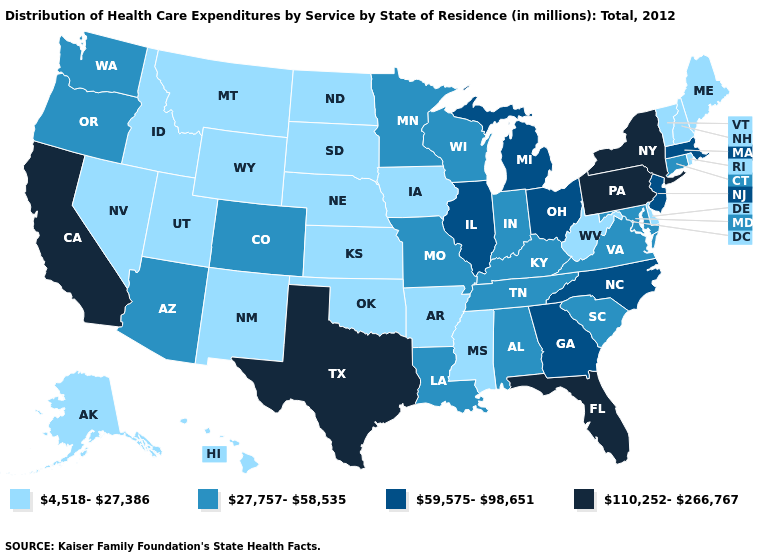Does Ohio have the highest value in the MidWest?
Write a very short answer. Yes. Which states have the highest value in the USA?
Be succinct. California, Florida, New York, Pennsylvania, Texas. What is the value of Washington?
Give a very brief answer. 27,757-58,535. Name the states that have a value in the range 27,757-58,535?
Concise answer only. Alabama, Arizona, Colorado, Connecticut, Indiana, Kentucky, Louisiana, Maryland, Minnesota, Missouri, Oregon, South Carolina, Tennessee, Virginia, Washington, Wisconsin. Does New Jersey have the same value as Nevada?
Short answer required. No. Does Missouri have the highest value in the USA?
Quick response, please. No. What is the value of Ohio?
Write a very short answer. 59,575-98,651. How many symbols are there in the legend?
Be succinct. 4. Among the states that border Utah , which have the highest value?
Answer briefly. Arizona, Colorado. What is the highest value in states that border Alabama?
Quick response, please. 110,252-266,767. What is the value of Missouri?
Be succinct. 27,757-58,535. Name the states that have a value in the range 59,575-98,651?
Short answer required. Georgia, Illinois, Massachusetts, Michigan, New Jersey, North Carolina, Ohio. Does Montana have the lowest value in the West?
Write a very short answer. Yes. Does Utah have the highest value in the West?
Quick response, please. No. What is the lowest value in the Northeast?
Quick response, please. 4,518-27,386. 